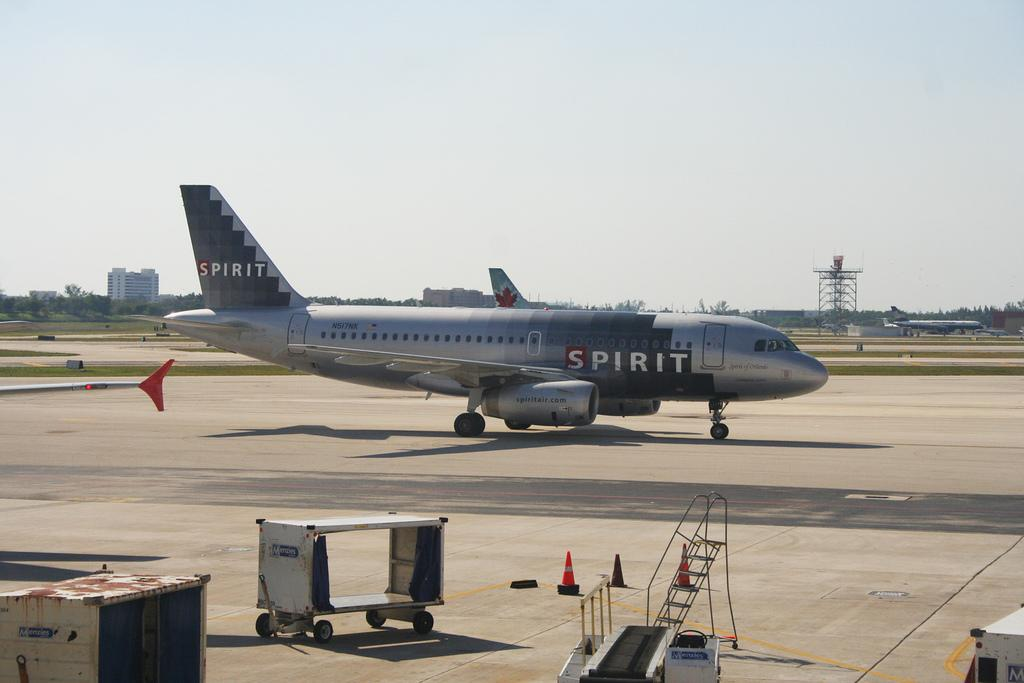<image>
Present a compact description of the photo's key features. A plane with the word Spirit painted on it in several places. 